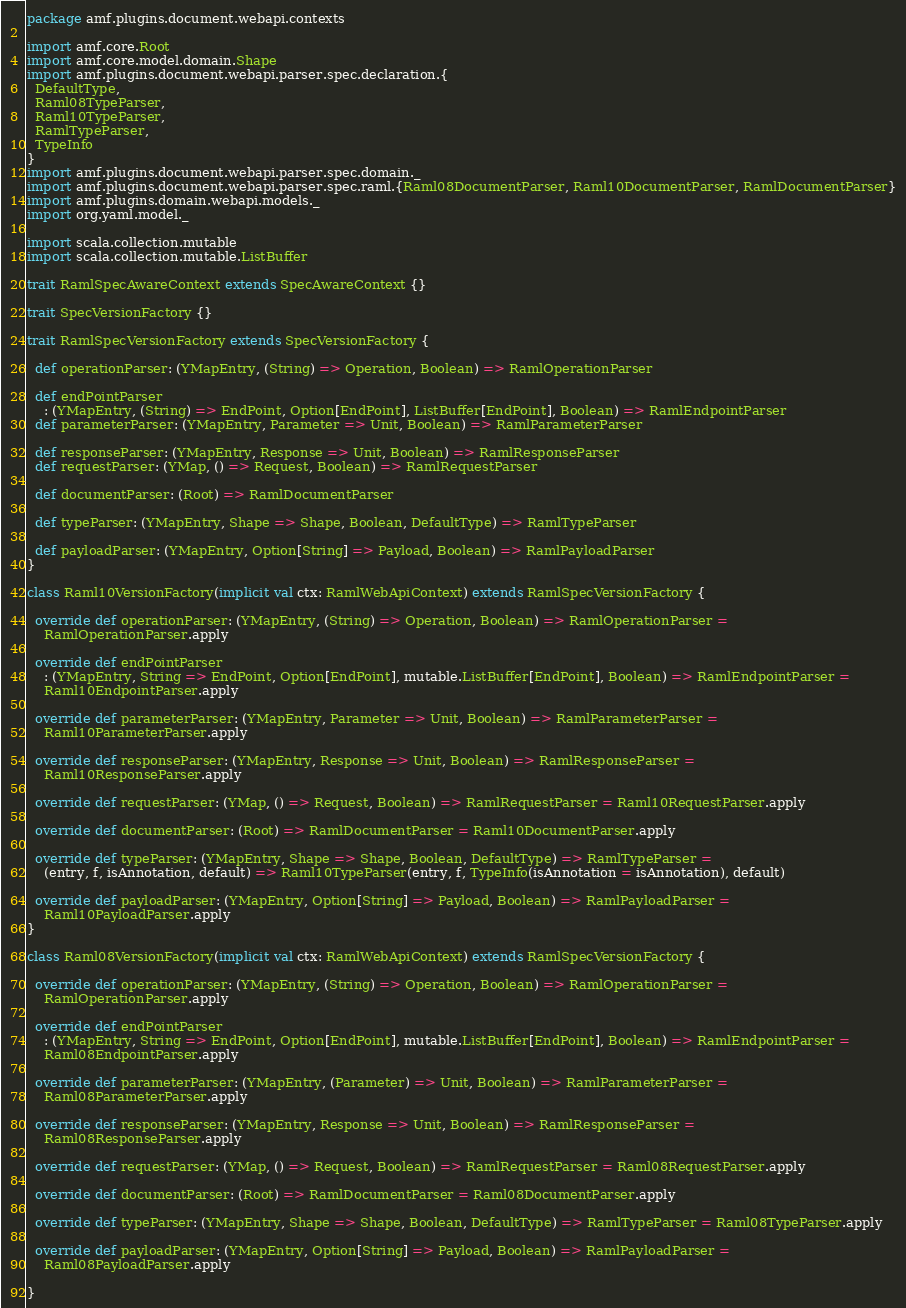Convert code to text. <code><loc_0><loc_0><loc_500><loc_500><_Scala_>package amf.plugins.document.webapi.contexts

import amf.core.Root
import amf.core.model.domain.Shape
import amf.plugins.document.webapi.parser.spec.declaration.{
  DefaultType,
  Raml08TypeParser,
  Raml10TypeParser,
  RamlTypeParser,
  TypeInfo
}
import amf.plugins.document.webapi.parser.spec.domain._
import amf.plugins.document.webapi.parser.spec.raml.{Raml08DocumentParser, Raml10DocumentParser, RamlDocumentParser}
import amf.plugins.domain.webapi.models._
import org.yaml.model._

import scala.collection.mutable
import scala.collection.mutable.ListBuffer

trait RamlSpecAwareContext extends SpecAwareContext {}

trait SpecVersionFactory {}

trait RamlSpecVersionFactory extends SpecVersionFactory {

  def operationParser: (YMapEntry, (String) => Operation, Boolean) => RamlOperationParser

  def endPointParser
    : (YMapEntry, (String) => EndPoint, Option[EndPoint], ListBuffer[EndPoint], Boolean) => RamlEndpointParser
  def parameterParser: (YMapEntry, Parameter => Unit, Boolean) => RamlParameterParser

  def responseParser: (YMapEntry, Response => Unit, Boolean) => RamlResponseParser
  def requestParser: (YMap, () => Request, Boolean) => RamlRequestParser

  def documentParser: (Root) => RamlDocumentParser

  def typeParser: (YMapEntry, Shape => Shape, Boolean, DefaultType) => RamlTypeParser

  def payloadParser: (YMapEntry, Option[String] => Payload, Boolean) => RamlPayloadParser
}

class Raml10VersionFactory(implicit val ctx: RamlWebApiContext) extends RamlSpecVersionFactory {

  override def operationParser: (YMapEntry, (String) => Operation, Boolean) => RamlOperationParser =
    RamlOperationParser.apply

  override def endPointParser
    : (YMapEntry, String => EndPoint, Option[EndPoint], mutable.ListBuffer[EndPoint], Boolean) => RamlEndpointParser =
    Raml10EndpointParser.apply

  override def parameterParser: (YMapEntry, Parameter => Unit, Boolean) => RamlParameterParser =
    Raml10ParameterParser.apply

  override def responseParser: (YMapEntry, Response => Unit, Boolean) => RamlResponseParser =
    Raml10ResponseParser.apply

  override def requestParser: (YMap, () => Request, Boolean) => RamlRequestParser = Raml10RequestParser.apply

  override def documentParser: (Root) => RamlDocumentParser = Raml10DocumentParser.apply

  override def typeParser: (YMapEntry, Shape => Shape, Boolean, DefaultType) => RamlTypeParser =
    (entry, f, isAnnotation, default) => Raml10TypeParser(entry, f, TypeInfo(isAnnotation = isAnnotation), default)

  override def payloadParser: (YMapEntry, Option[String] => Payload, Boolean) => RamlPayloadParser =
    Raml10PayloadParser.apply
}

class Raml08VersionFactory(implicit val ctx: RamlWebApiContext) extends RamlSpecVersionFactory {

  override def operationParser: (YMapEntry, (String) => Operation, Boolean) => RamlOperationParser =
    RamlOperationParser.apply

  override def endPointParser
    : (YMapEntry, String => EndPoint, Option[EndPoint], mutable.ListBuffer[EndPoint], Boolean) => RamlEndpointParser =
    Raml08EndpointParser.apply

  override def parameterParser: (YMapEntry, (Parameter) => Unit, Boolean) => RamlParameterParser =
    Raml08ParameterParser.apply

  override def responseParser: (YMapEntry, Response => Unit, Boolean) => RamlResponseParser =
    Raml08ResponseParser.apply

  override def requestParser: (YMap, () => Request, Boolean) => RamlRequestParser = Raml08RequestParser.apply

  override def documentParser: (Root) => RamlDocumentParser = Raml08DocumentParser.apply

  override def typeParser: (YMapEntry, Shape => Shape, Boolean, DefaultType) => RamlTypeParser = Raml08TypeParser.apply

  override def payloadParser: (YMapEntry, Option[String] => Payload, Boolean) => RamlPayloadParser =
    Raml08PayloadParser.apply

}
</code> 